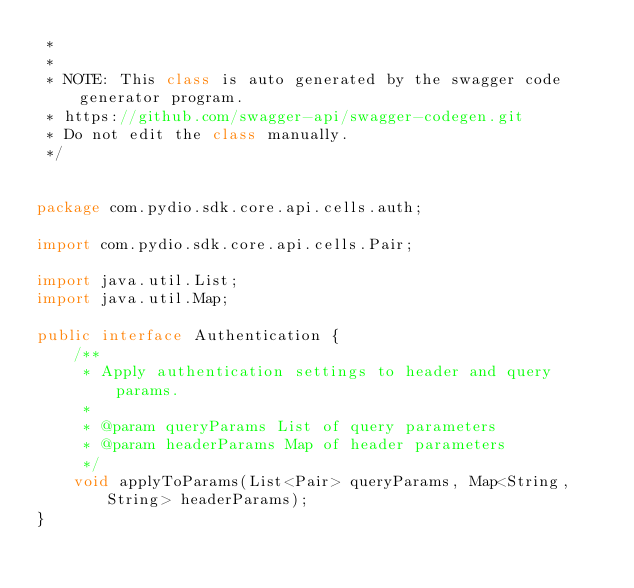Convert code to text. <code><loc_0><loc_0><loc_500><loc_500><_Java_> * 
 *
 * NOTE: This class is auto generated by the swagger code generator program.
 * https://github.com/swagger-api/swagger-codegen.git
 * Do not edit the class manually.
 */


package com.pydio.sdk.core.api.cells.auth;

import com.pydio.sdk.core.api.cells.Pair;

import java.util.List;
import java.util.Map;

public interface Authentication {
    /**
     * Apply authentication settings to header and query params.
     *
     * @param queryParams List of query parameters
     * @param headerParams Map of header parameters
     */
    void applyToParams(List<Pair> queryParams, Map<String, String> headerParams);
}
</code> 